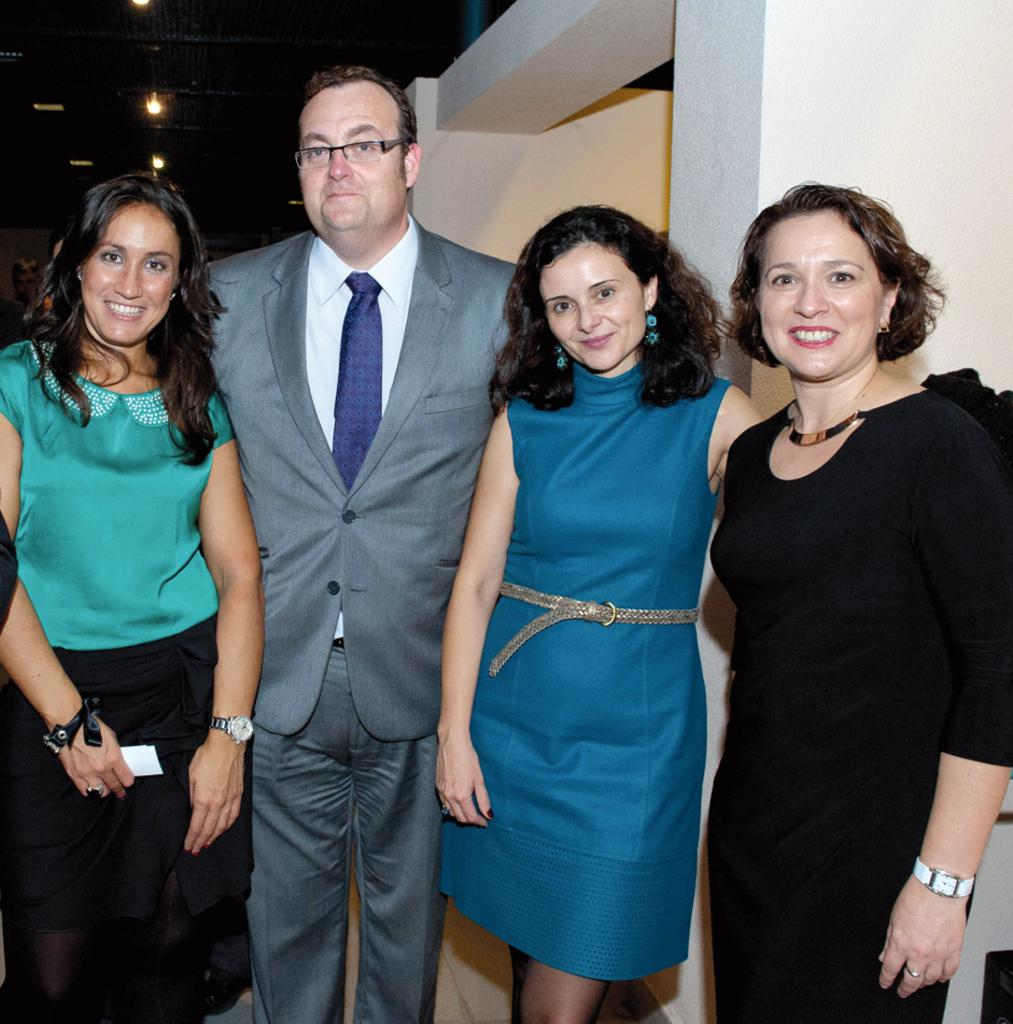How many people are present in the image? There are four people in the image. What are the people doing in the image? The people are standing and smiling. What can be seen in the background of the image? There are walls visible in the image. Is there at least one person in the image? Yes, there are four people in the image. What is located on top in the image? There are lights on top in the image. How many trees can be seen in the image? There are no trees visible in the image. How many children are present in the image? There is there any indication of respect in the image? 